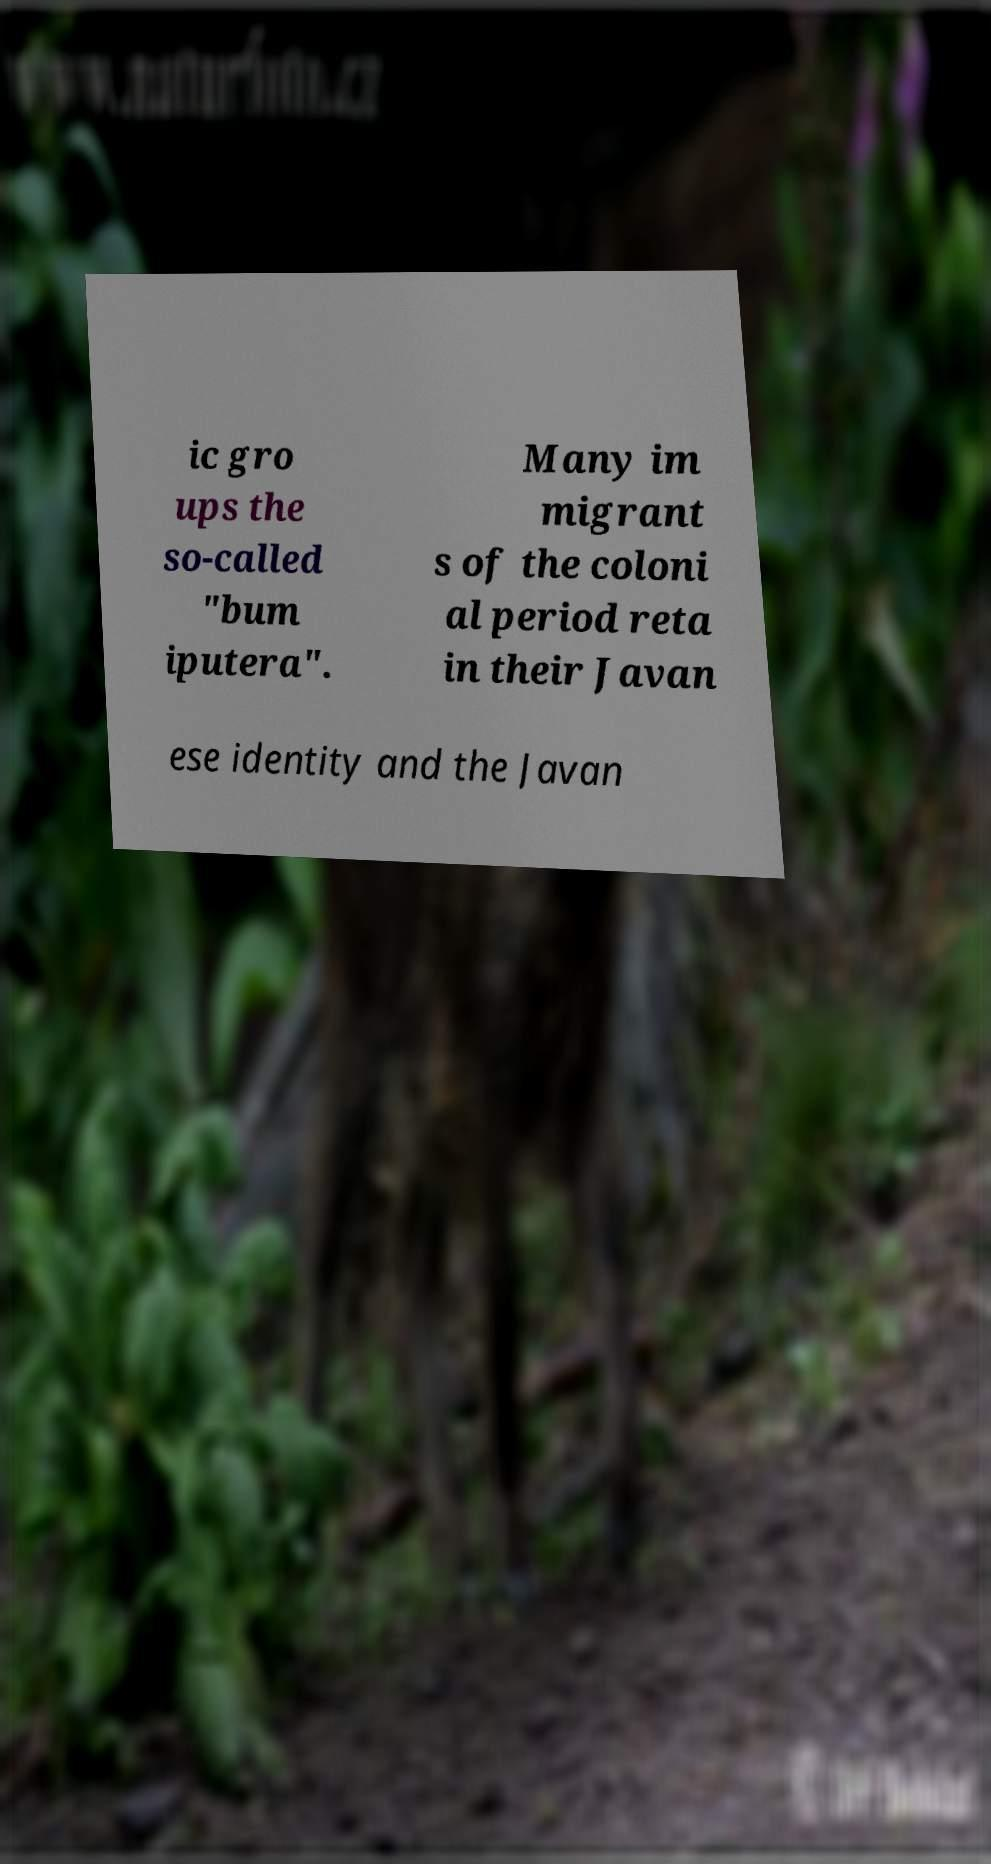Could you extract and type out the text from this image? ic gro ups the so-called "bum iputera". Many im migrant s of the coloni al period reta in their Javan ese identity and the Javan 